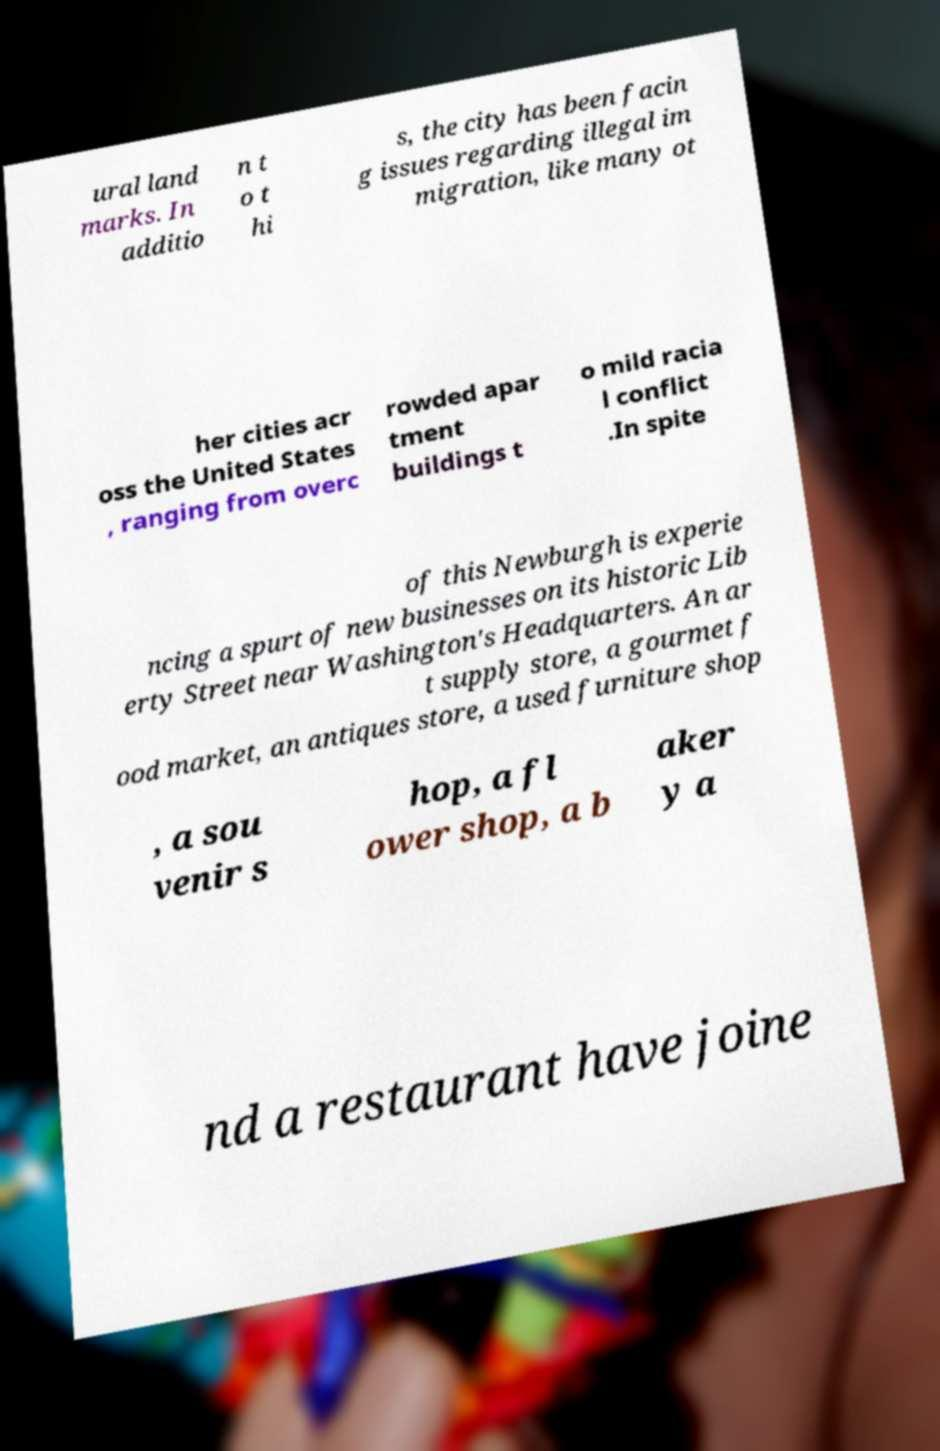Can you accurately transcribe the text from the provided image for me? ural land marks. In additio n t o t hi s, the city has been facin g issues regarding illegal im migration, like many ot her cities acr oss the United States , ranging from overc rowded apar tment buildings t o mild racia l conflict .In spite of this Newburgh is experie ncing a spurt of new businesses on its historic Lib erty Street near Washington's Headquarters. An ar t supply store, a gourmet f ood market, an antiques store, a used furniture shop , a sou venir s hop, a fl ower shop, a b aker y a nd a restaurant have joine 